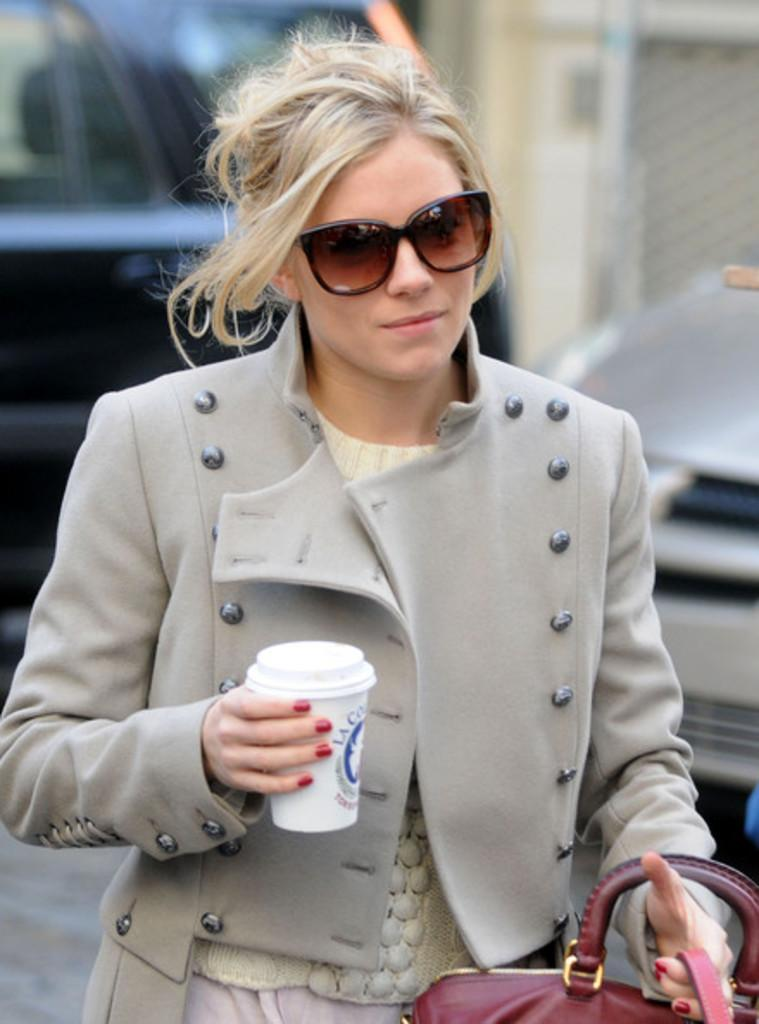Who is present in the image? There is a woman in the image. What is the woman doing in the image? The woman is standing in the image. What objects is the woman holding? The woman is holding a glass and a bag in the image. What can be seen in the background of the image? There is a car and a wall in the background of the image. What type of prose is the woman reading in the image? There is no indication in the image that the woman is reading any prose, as she is holding a glass and a bag, and there is no book or text visible. 